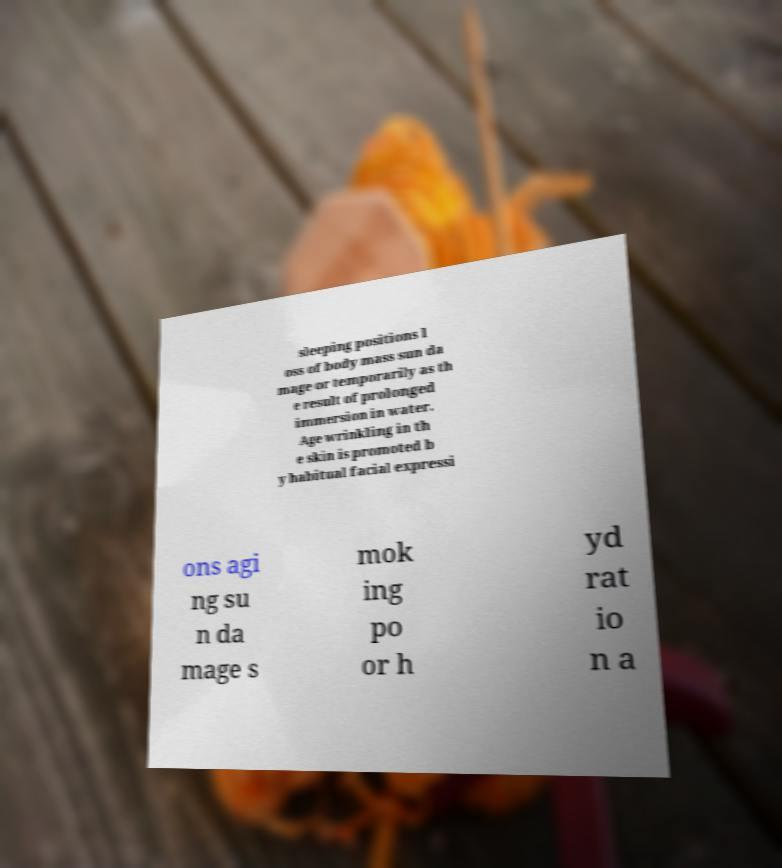Please identify and transcribe the text found in this image. sleeping positions l oss of body mass sun da mage or temporarily as th e result of prolonged immersion in water. Age wrinkling in th e skin is promoted b y habitual facial expressi ons agi ng su n da mage s mok ing po or h yd rat io n a 